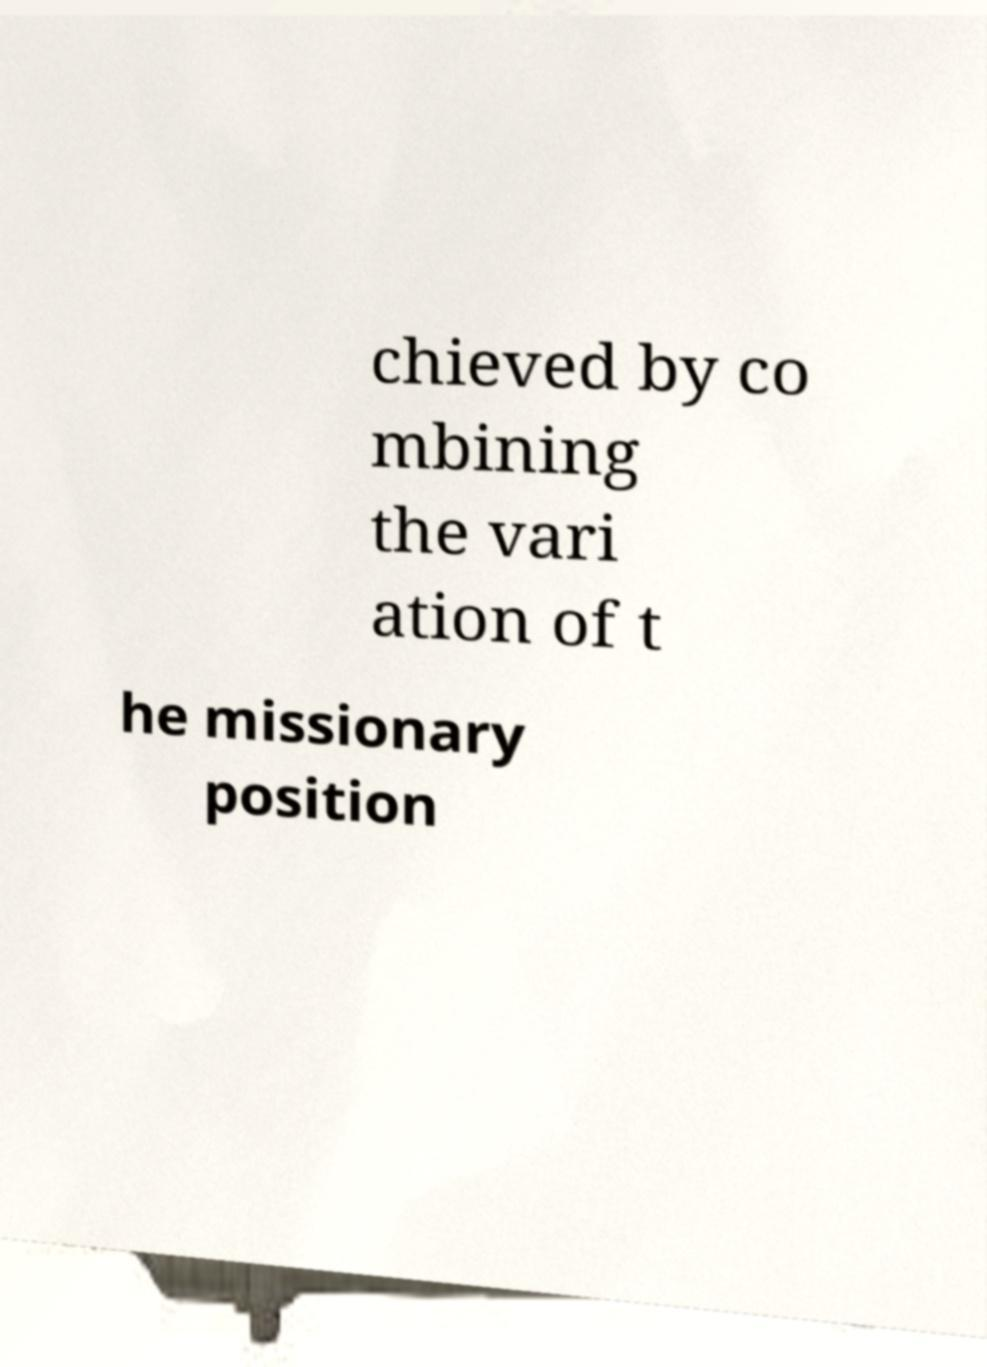Please read and relay the text visible in this image. What does it say? chieved by co mbining the vari ation of t he missionary position 